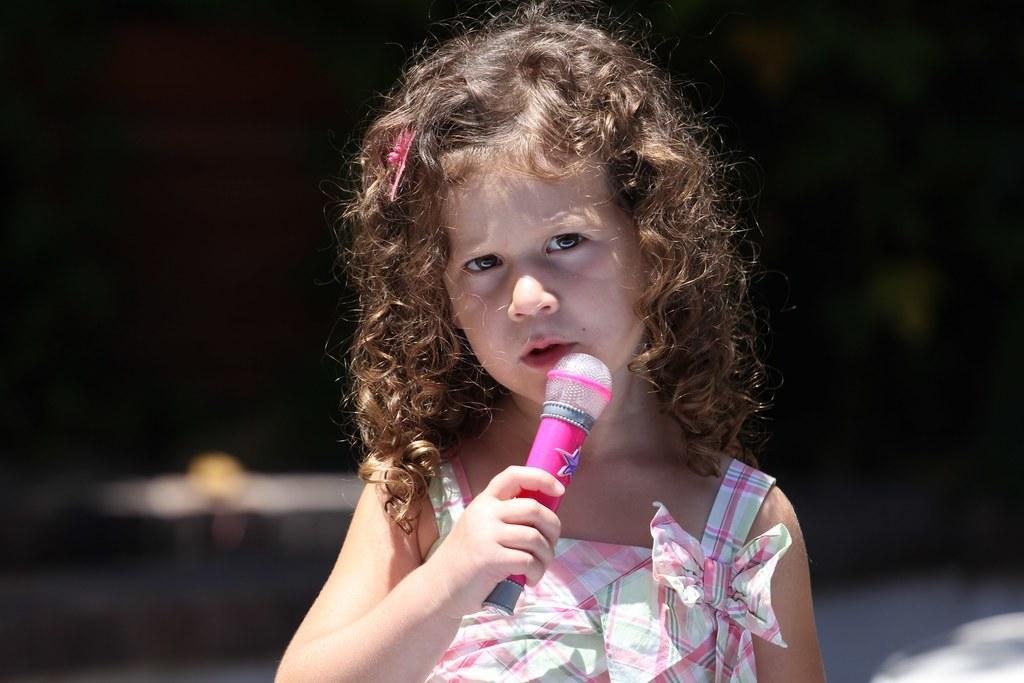Could you give a brief overview of what you see in this image? In this image, In the middle there is a girl standing and she is holding a plastic microphone which is in pink color. 